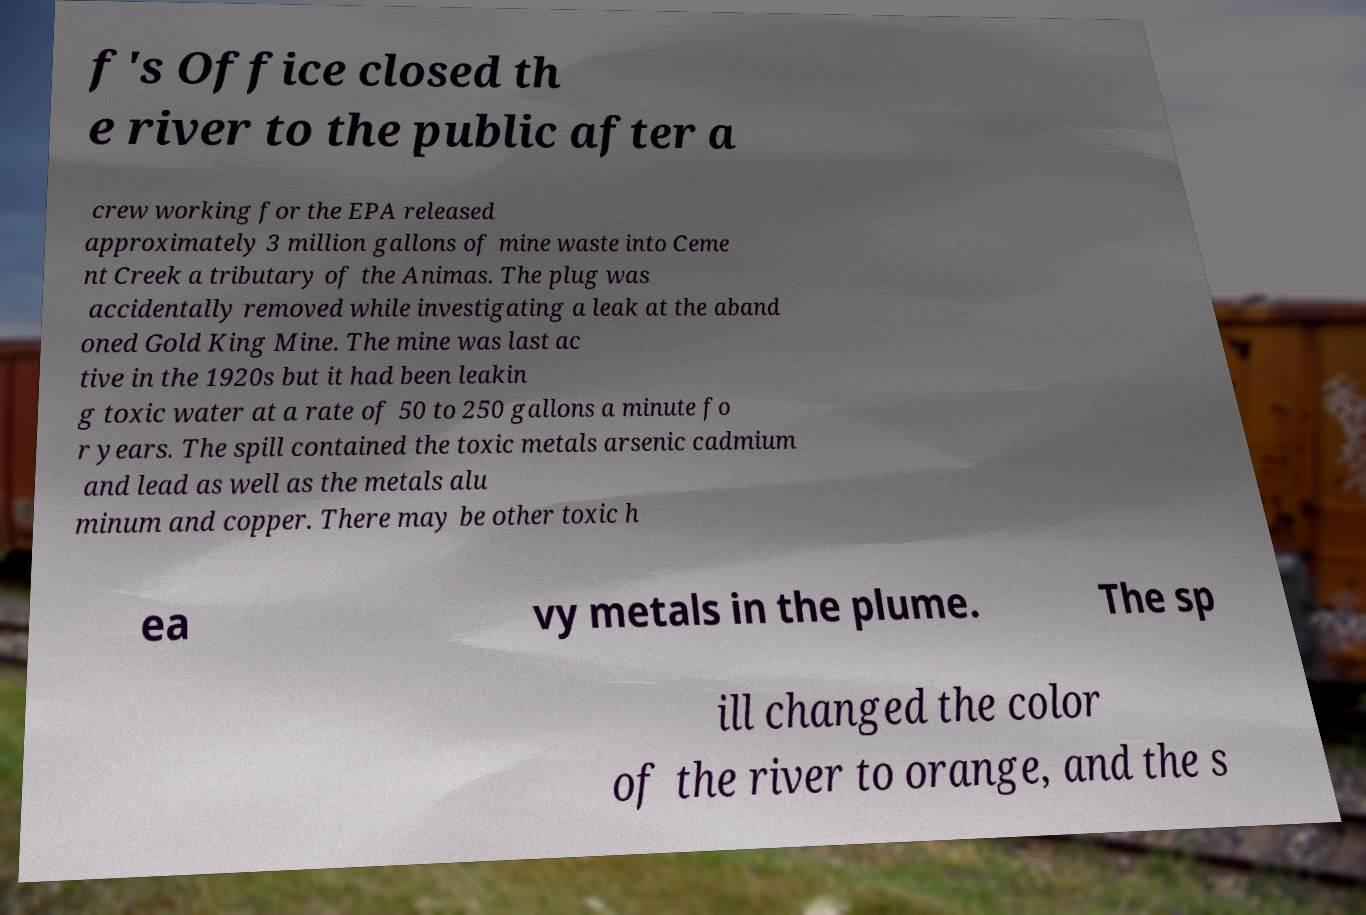For documentation purposes, I need the text within this image transcribed. Could you provide that? f's Office closed th e river to the public after a crew working for the EPA released approximately 3 million gallons of mine waste into Ceme nt Creek a tributary of the Animas. The plug was accidentally removed while investigating a leak at the aband oned Gold King Mine. The mine was last ac tive in the 1920s but it had been leakin g toxic water at a rate of 50 to 250 gallons a minute fo r years. The spill contained the toxic metals arsenic cadmium and lead as well as the metals alu minum and copper. There may be other toxic h ea vy metals in the plume. The sp ill changed the color of the river to orange, and the s 